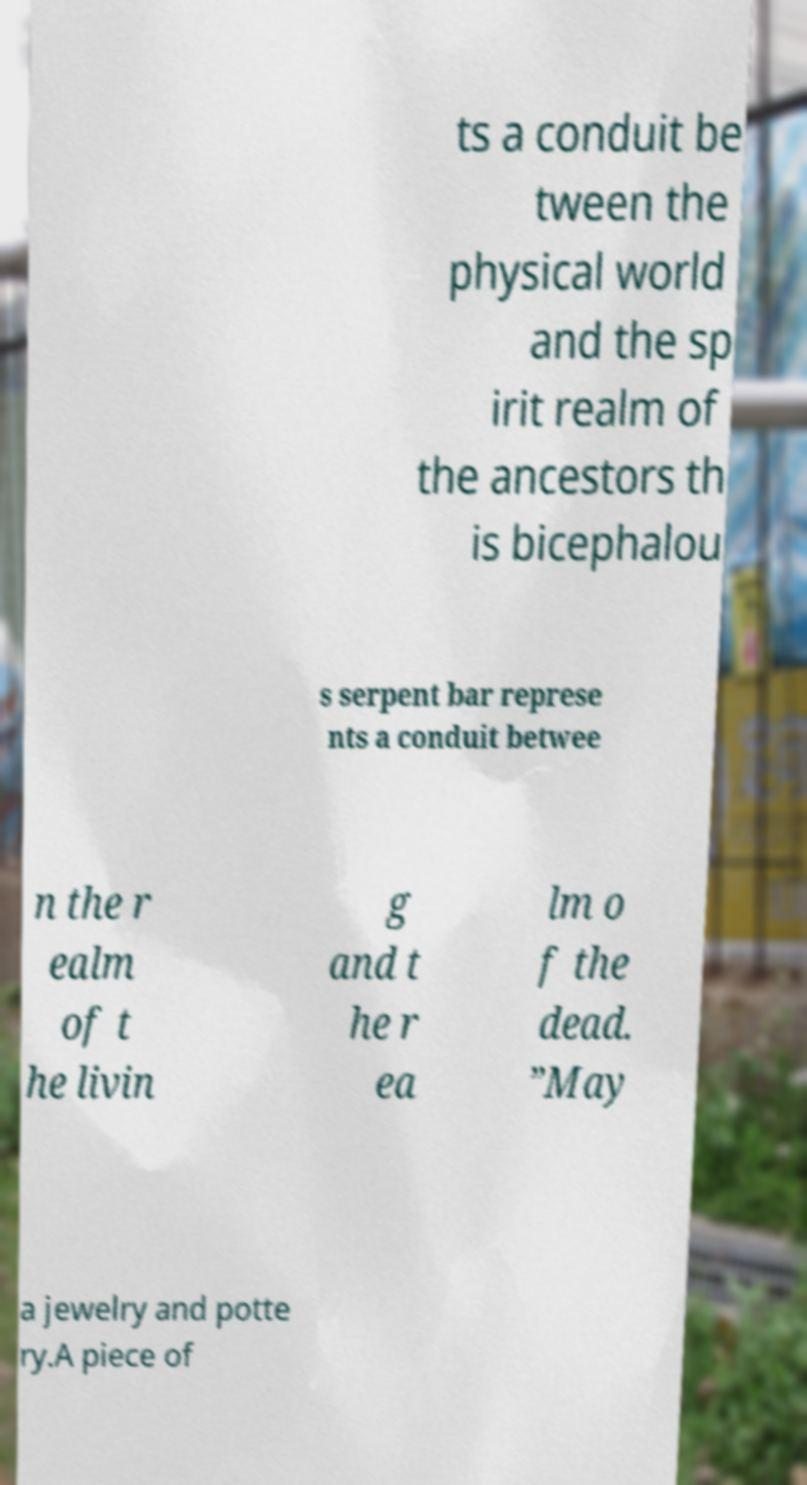Could you extract and type out the text from this image? ts a conduit be tween the physical world and the sp irit realm of the ancestors th is bicephalou s serpent bar represe nts a conduit betwee n the r ealm of t he livin g and t he r ea lm o f the dead. ”May a jewelry and potte ry.A piece of 